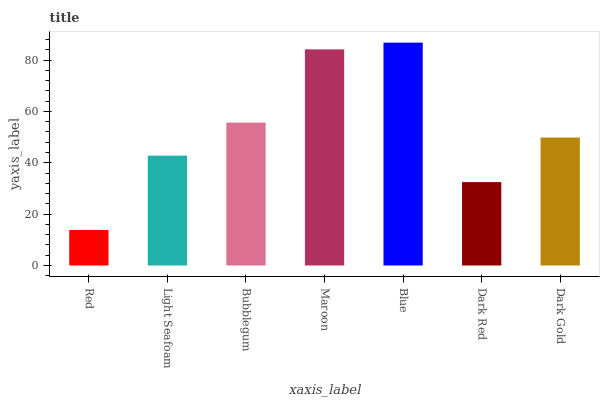Is Red the minimum?
Answer yes or no. Yes. Is Blue the maximum?
Answer yes or no. Yes. Is Light Seafoam the minimum?
Answer yes or no. No. Is Light Seafoam the maximum?
Answer yes or no. No. Is Light Seafoam greater than Red?
Answer yes or no. Yes. Is Red less than Light Seafoam?
Answer yes or no. Yes. Is Red greater than Light Seafoam?
Answer yes or no. No. Is Light Seafoam less than Red?
Answer yes or no. No. Is Dark Gold the high median?
Answer yes or no. Yes. Is Dark Gold the low median?
Answer yes or no. Yes. Is Maroon the high median?
Answer yes or no. No. Is Light Seafoam the low median?
Answer yes or no. No. 